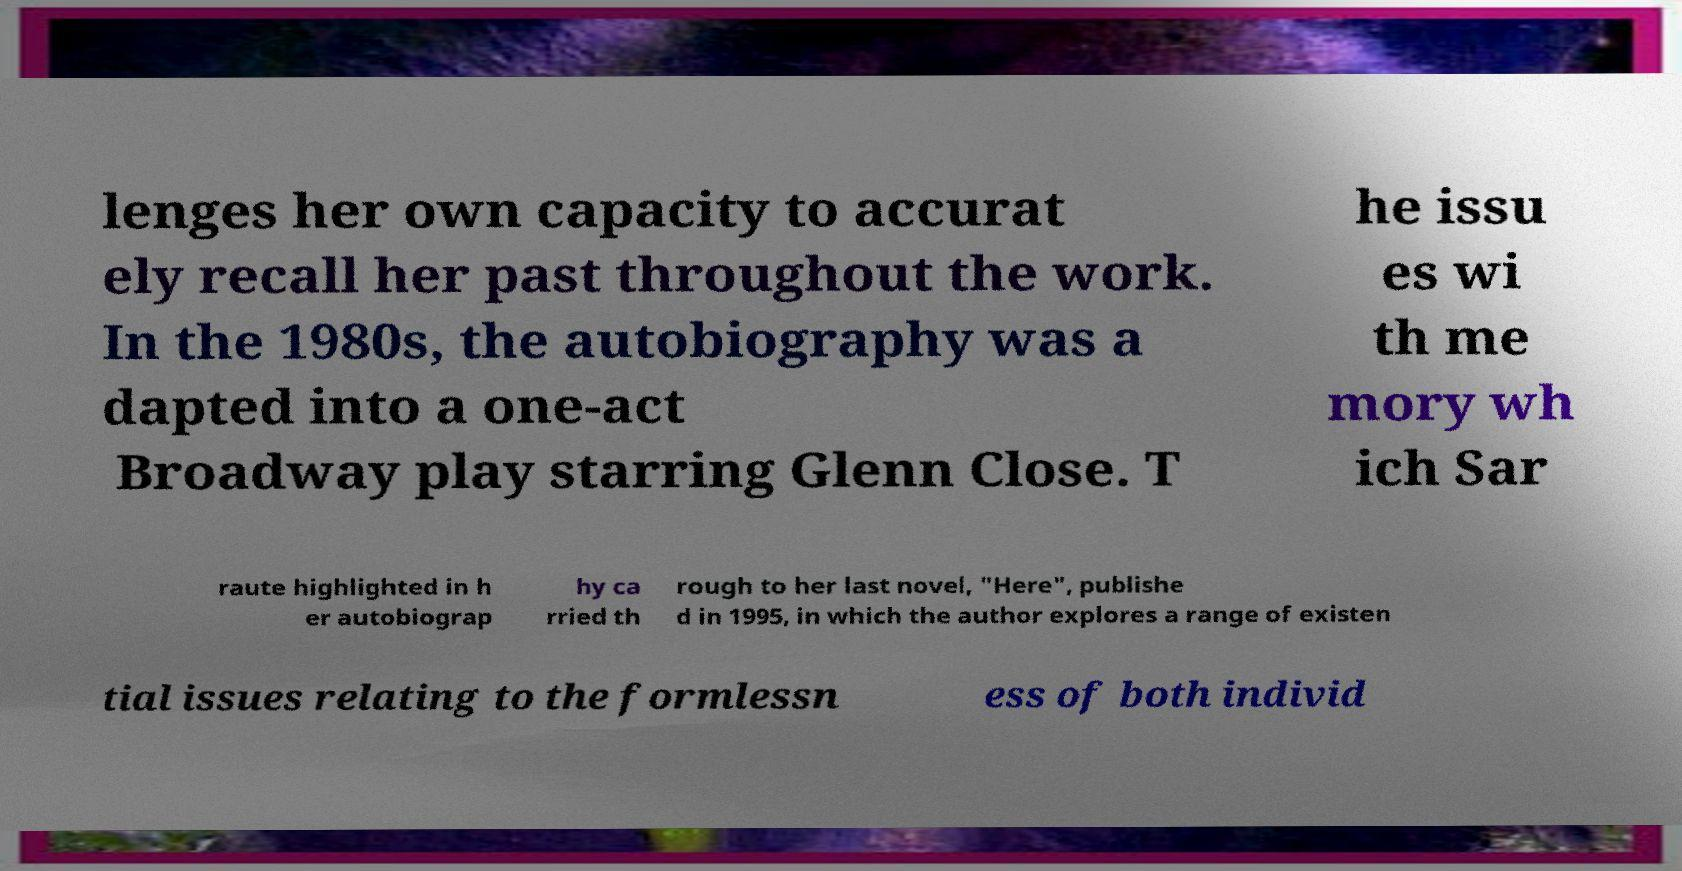For documentation purposes, I need the text within this image transcribed. Could you provide that? lenges her own capacity to accurat ely recall her past throughout the work. In the 1980s, the autobiography was a dapted into a one-act Broadway play starring Glenn Close. T he issu es wi th me mory wh ich Sar raute highlighted in h er autobiograp hy ca rried th rough to her last novel, "Here", publishe d in 1995, in which the author explores a range of existen tial issues relating to the formlessn ess of both individ 